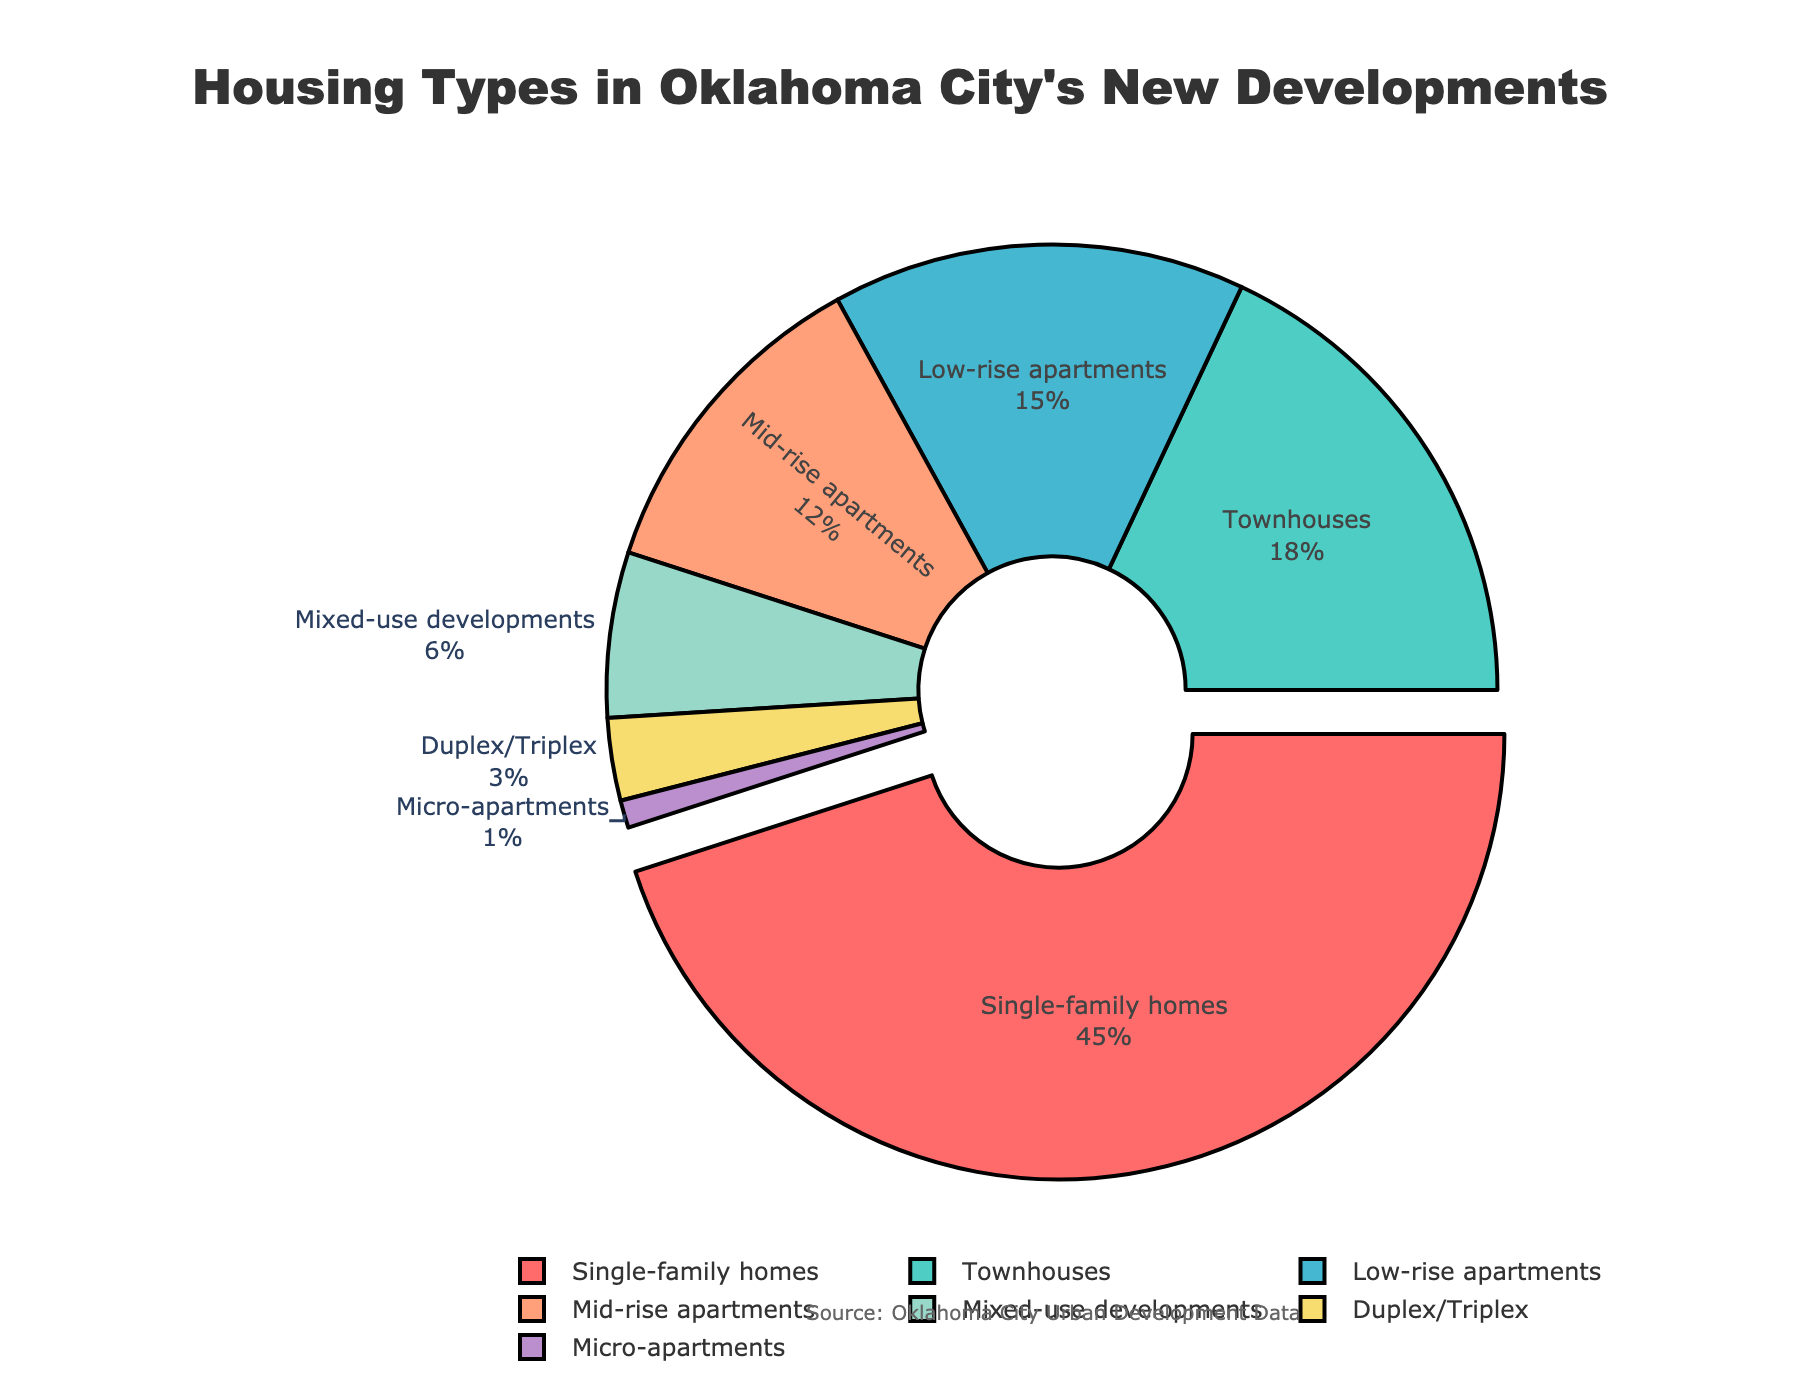What is the housing type with the highest percentage in Oklahoma City's new developments? By looking at the figure, we can see that the segment for Single-family homes is distinctly pulled out from the rest of the pie chart, indicating it has the highest percentage. Additionally, its label reads 45%.
Answer: Single-family homes How does the percentage of Townhouses compare to that of Mixed-use developments? To compare, we refer to the labels on the pie chart: Townhouses have 18% and Mixed-use developments have 6%. Comparing these, Townhouses have a higher percentage.
Answer: Townhouses have a higher percentage What is the combined percentage of Low-rise apartments and Mid-rise apartments? Adding the percentages of Low-rise apartments (15%) and Mid-rise apartments (12%) gives us 15 + 12.
Answer: 27% Which two housing types have the smallest slices in the pie chart, and what are their combined percentages? By visually identifying the smallest slices, we see Duplex/Triplex at 3% and Micro-apartments at 1%. Adding these percentages gives us 3 + 1.
Answer: Duplex/Triplex and Micro-apartments, 4% What percentage of housing types in new developments are apartments (Low-rise, Mid-rise, and Micro-apartments)? To find the total percentage of apartments, add the percentages for Low-rise (15%), Mid-rise (12%), and Micro-apartments (1%). 15 + 12 + 1 equals 28%.
Answer: 28% By how much does the percentage of Single-family homes exceed that of Mid-rise apartments? Subtract the percentage of Mid-rise apartments (12%) from Single-family homes (45%). 45 - 12 equals 33%.
Answer: 33% What's the difference between the percentages of Duplex/Triplex and Mixed-use developments? Subtract the percentage of Duplex/Triplex (3%) from Mixed-use developments (6%). 6 - 3 equals 3%.
Answer: 3% Which housing types combined make up more than half of the new development housing types? Adding the percentages in descending order until the sum exceeds 50%: Single-family homes (45%) and Townhouses (18%) together make 45 + 18 = 63%, which is more than half.
Answer: Single-family homes and Townhouses 